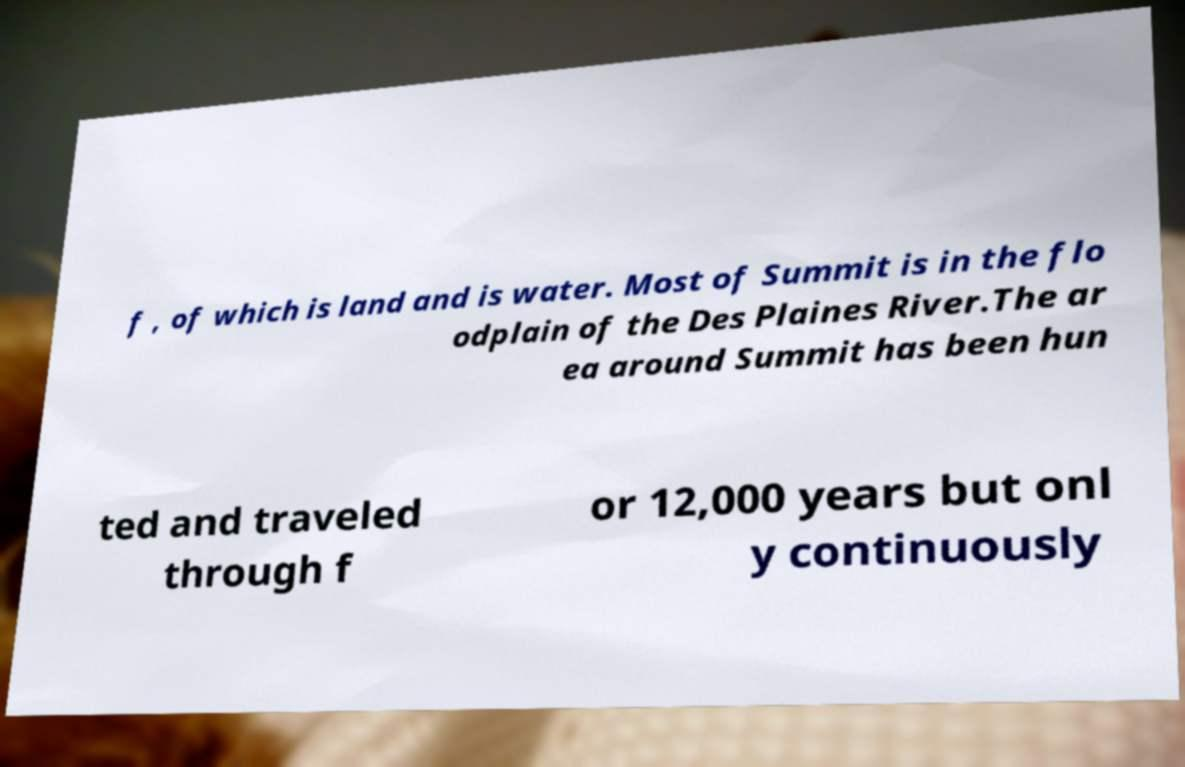Please identify and transcribe the text found in this image. f , of which is land and is water. Most of Summit is in the flo odplain of the Des Plaines River.The ar ea around Summit has been hun ted and traveled through f or 12,000 years but onl y continuously 